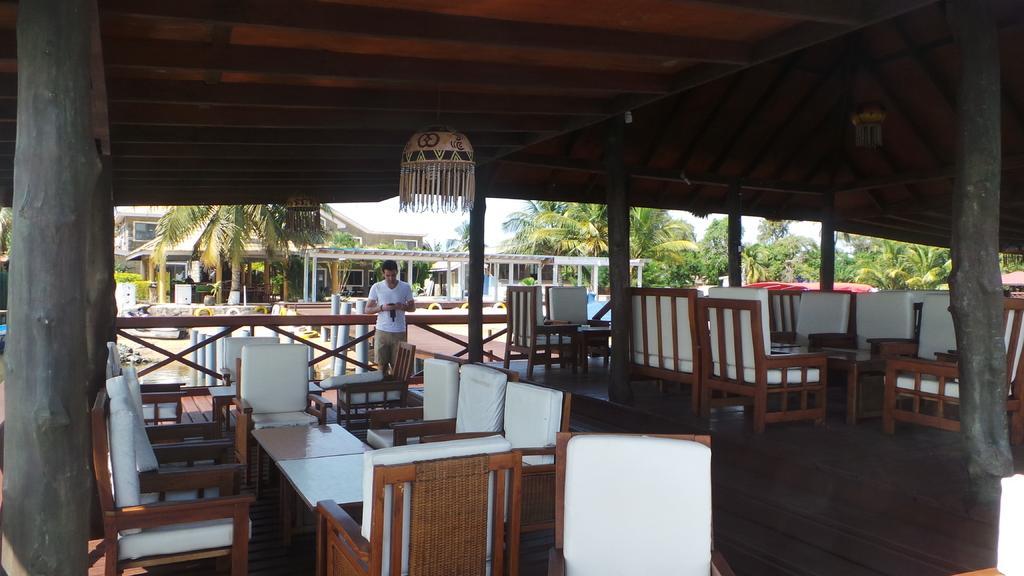Please provide a concise description of this image. This picture shows few chairs and tables and we see a man standing and is holding a camera in his hand and we see a building and few trees and few decorative hangings to the roof. 